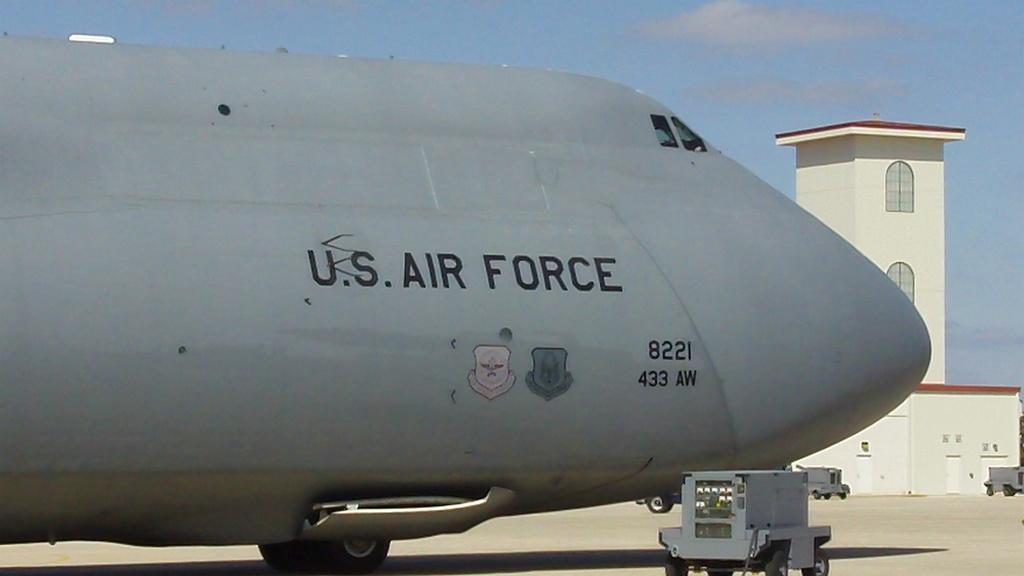Describe this image in one or two sentences. This image consists of an airplane. There is a building on the right side. There is sky at the top. 